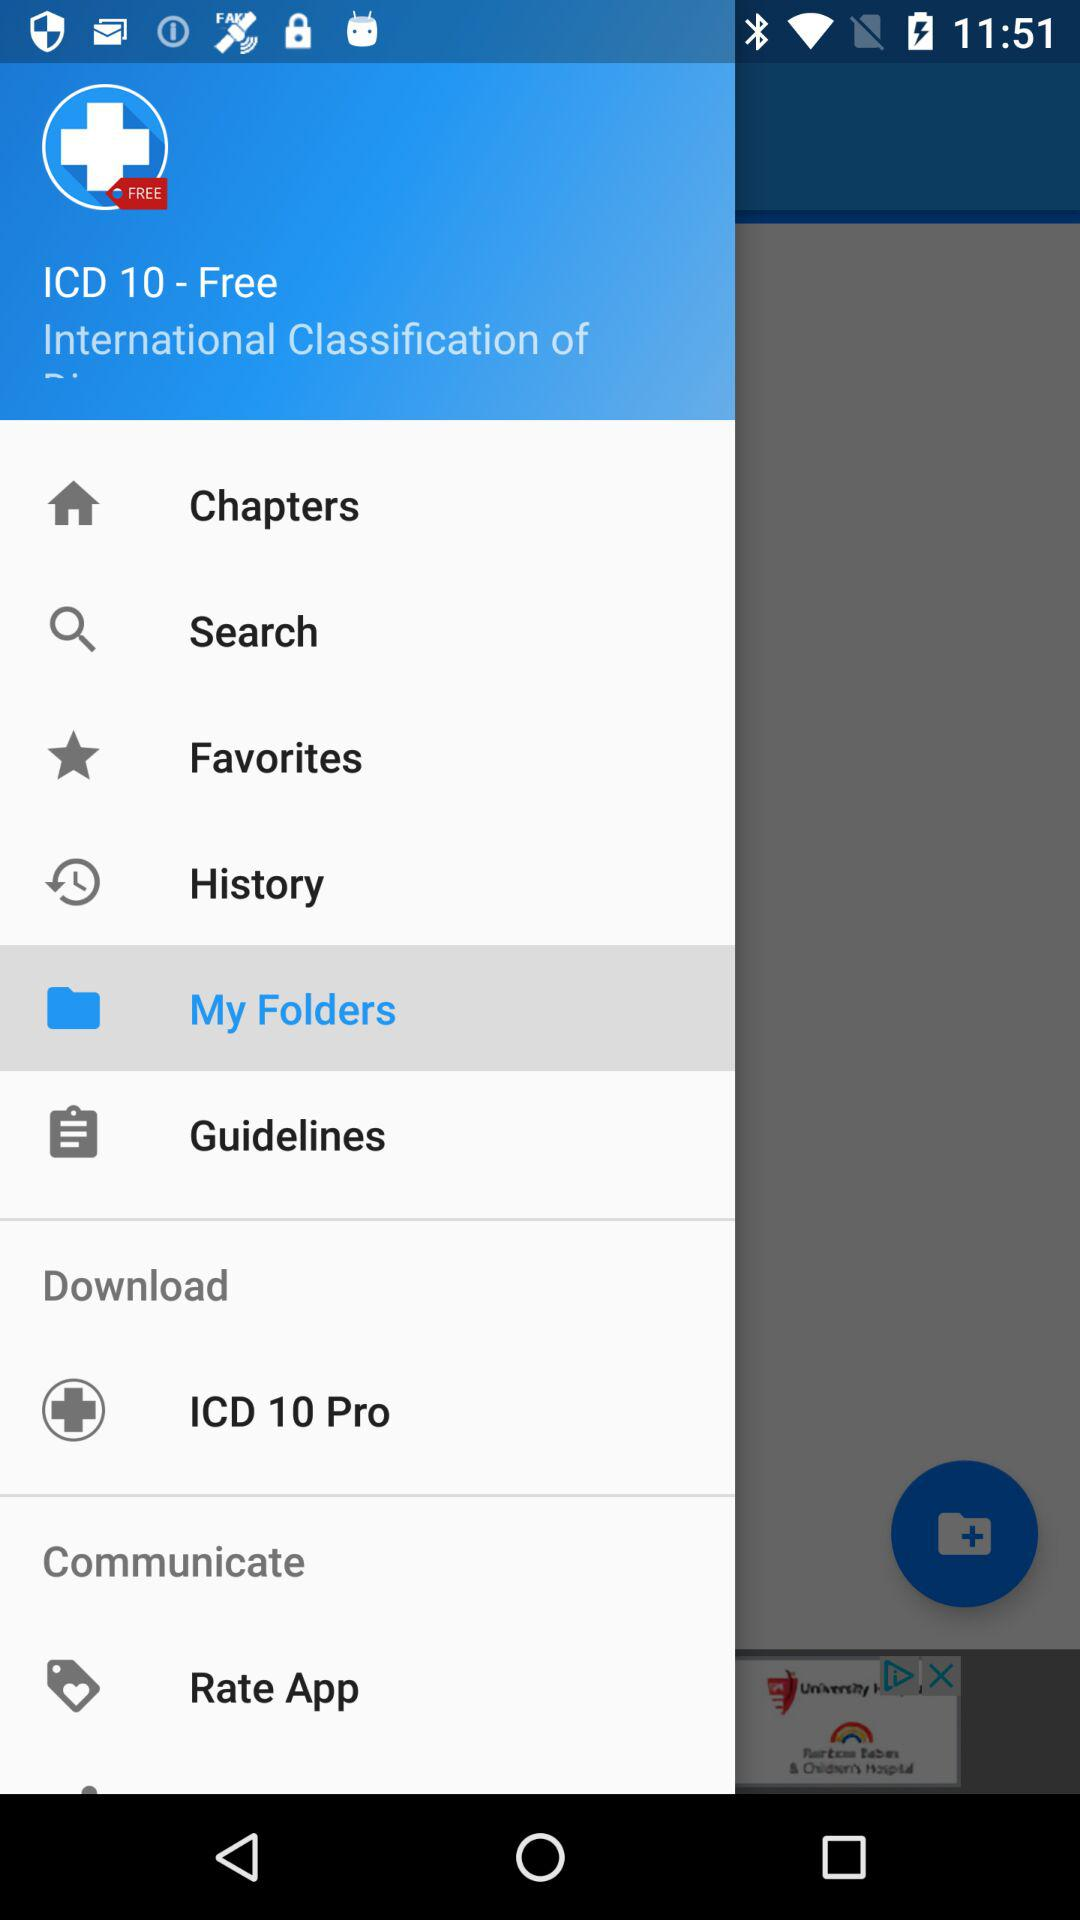What is the name of the application? The name of the application is "ICD 10 - Free". 